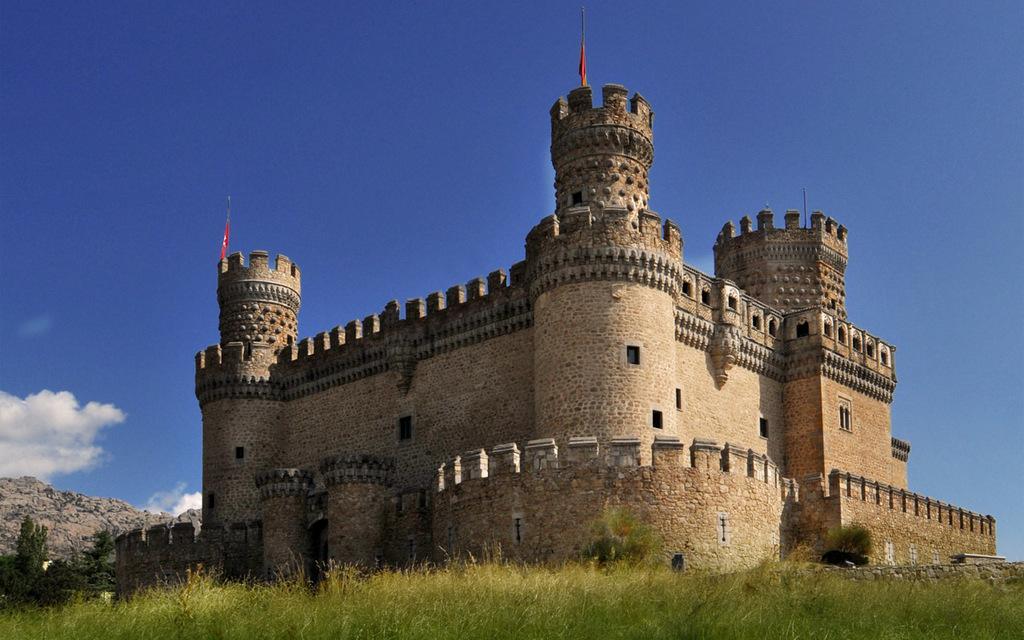Describe this image in one or two sentences. In this picture I can observe monument in the middle of the picture. In the bottom of the picture I can observe some grass on the ground. In the background I can observe sky. 